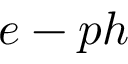<formula> <loc_0><loc_0><loc_500><loc_500>e - p h</formula> 